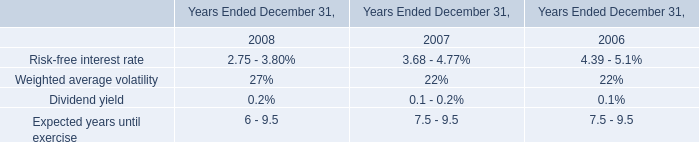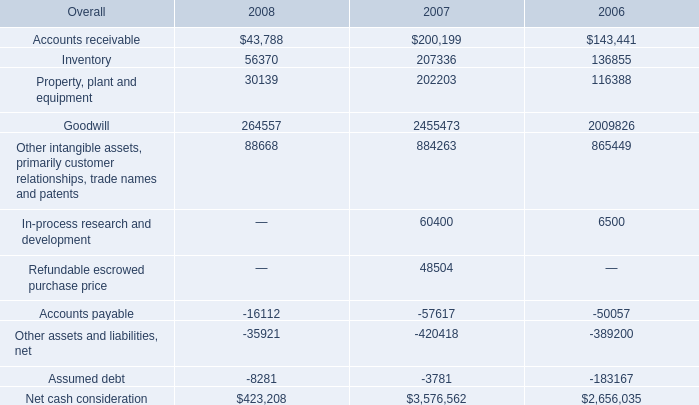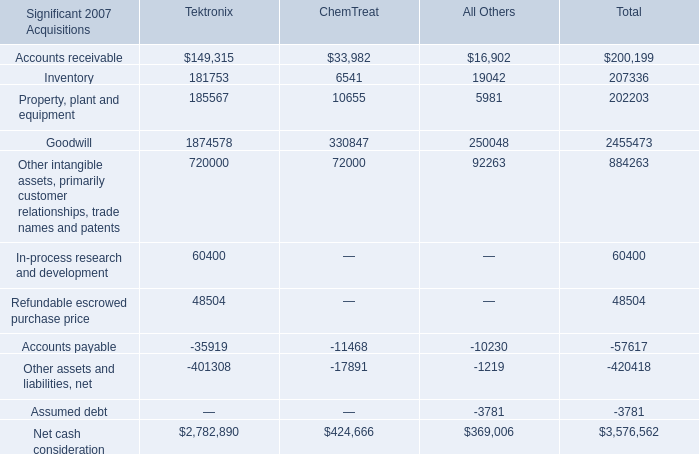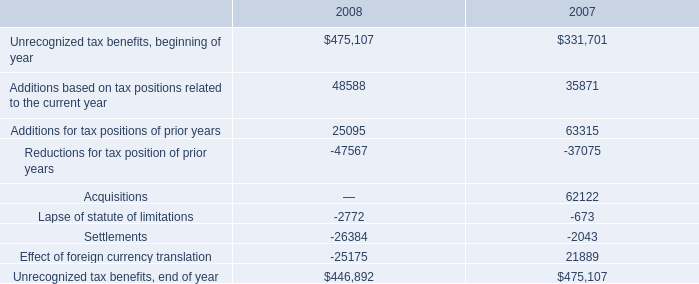What's the average of Accounts receivable of Tektronix, and Accounts payable of 2006 ? 
Computations: ((149315.0 + 50057.0) / 2)
Answer: 99686.0. 